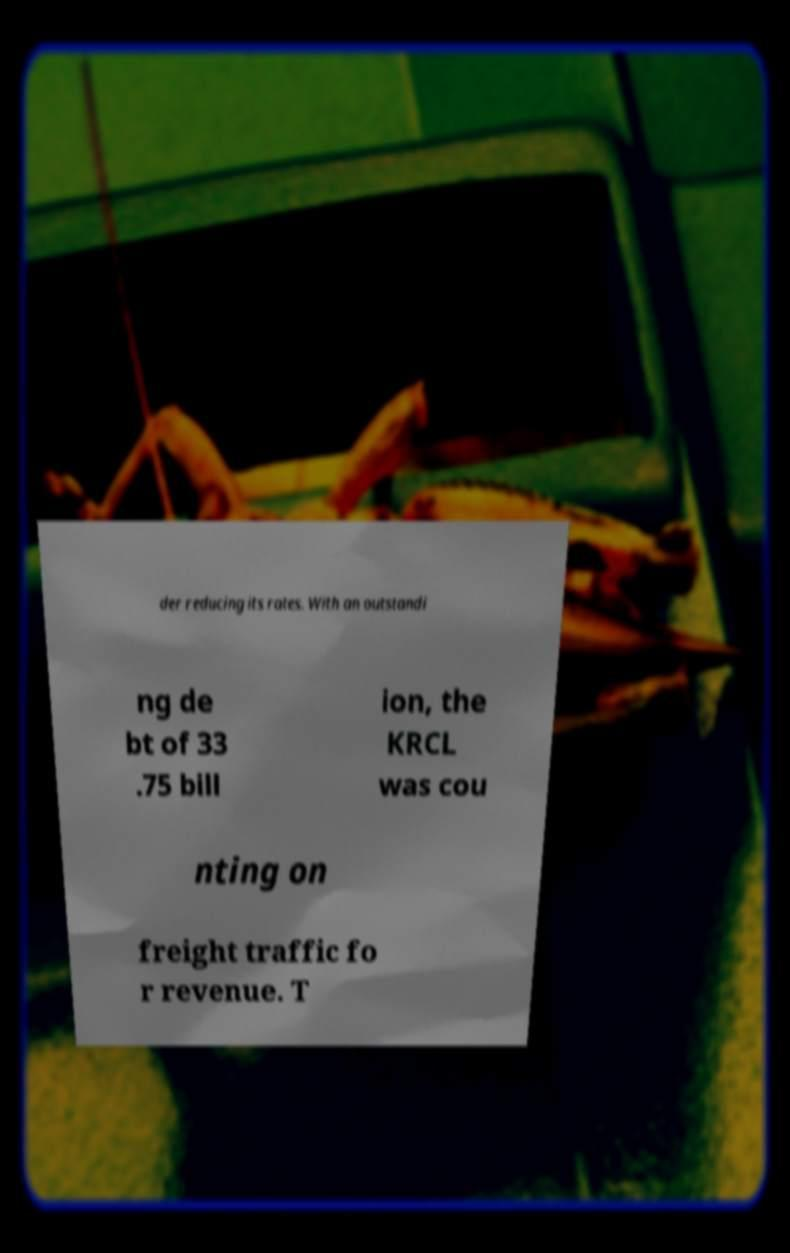Please read and relay the text visible in this image. What does it say? der reducing its rates. With an outstandi ng de bt of 33 .75 bill ion, the KRCL was cou nting on freight traffic fo r revenue. T 